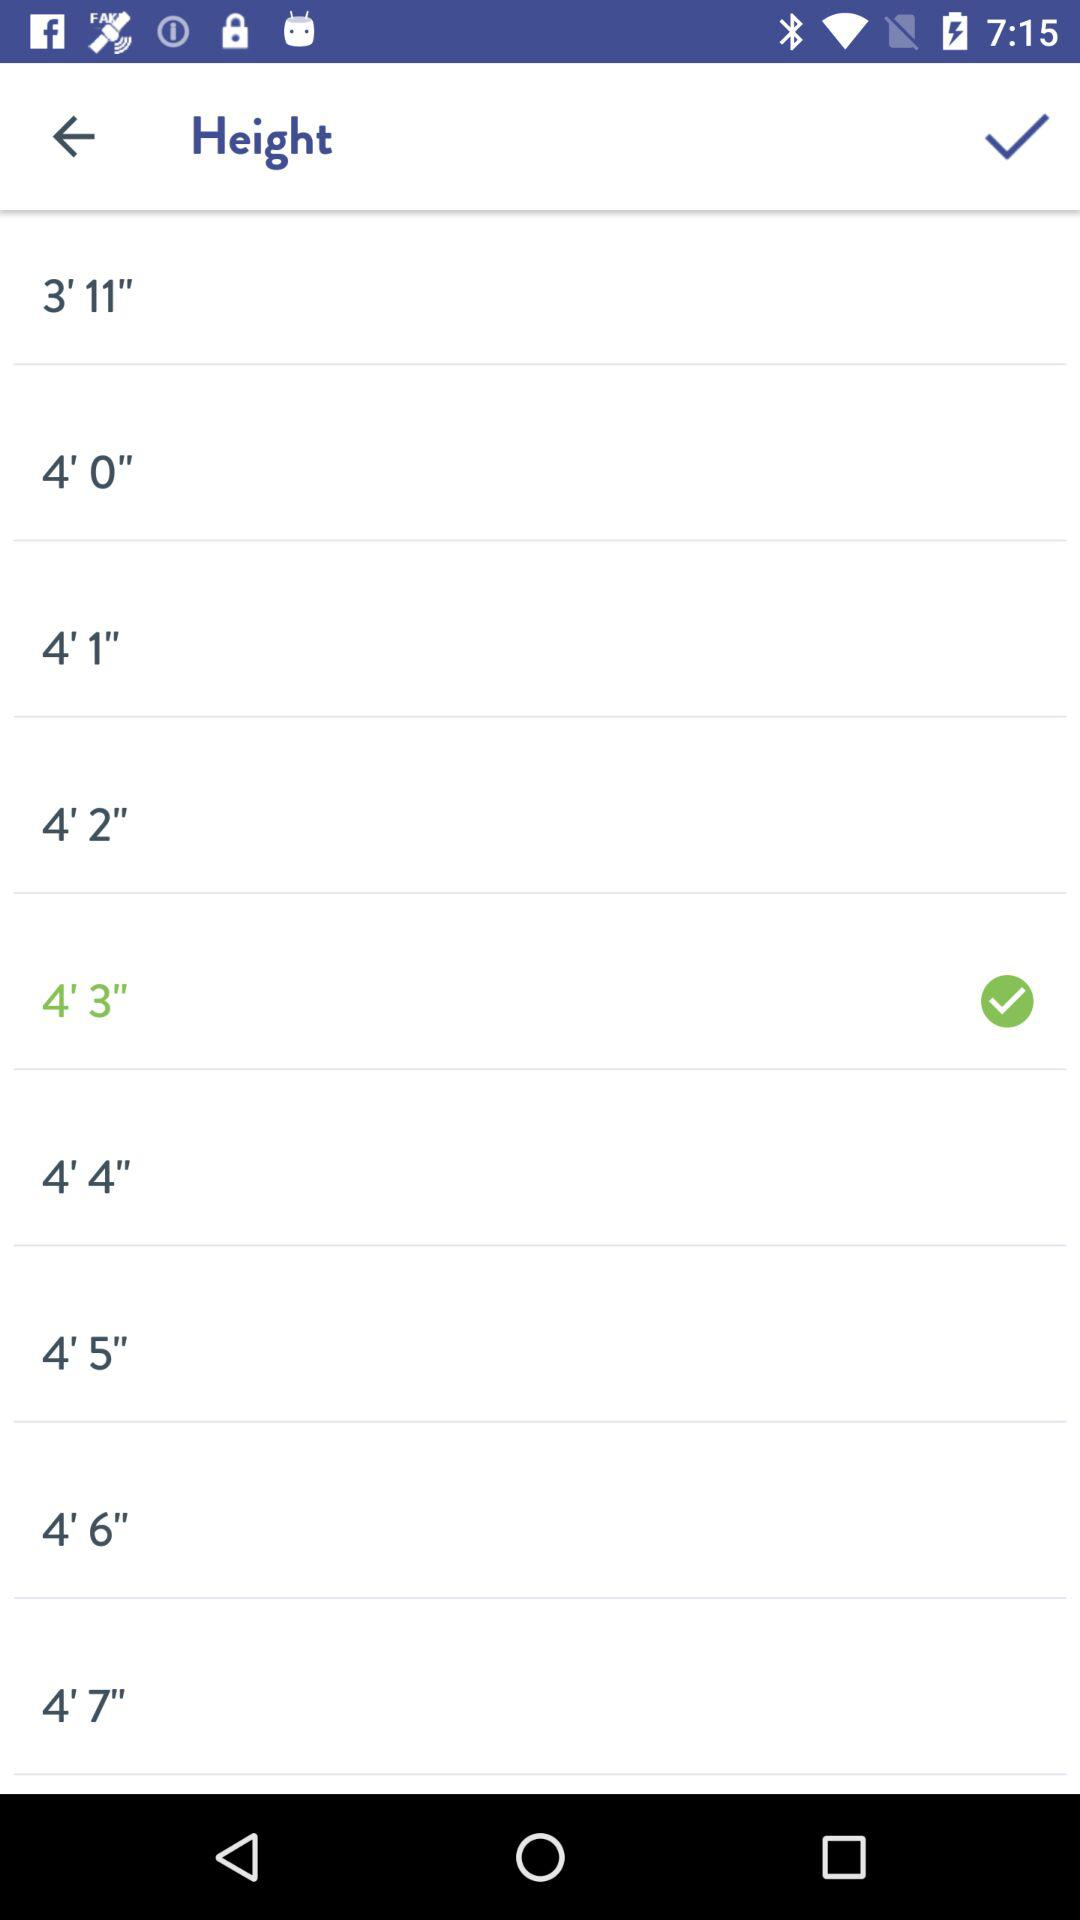How many inches taller is 4'6" than 4'3"
Answer the question using a single word or phrase. 3 